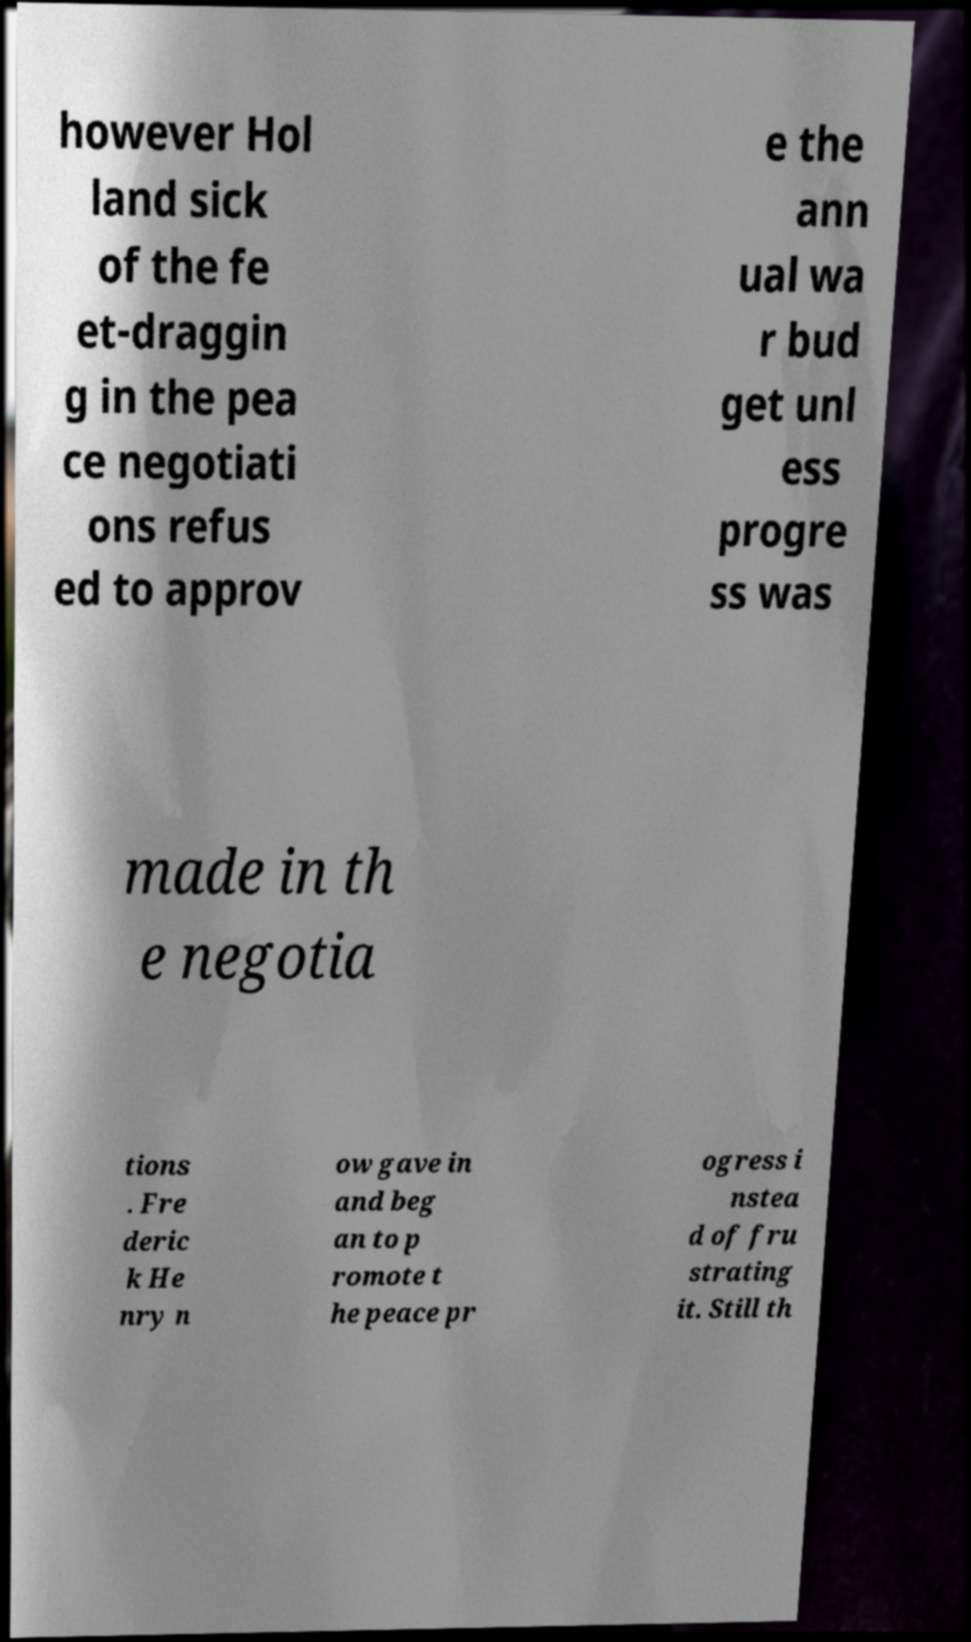What messages or text are displayed in this image? I need them in a readable, typed format. however Hol land sick of the fe et-draggin g in the pea ce negotiati ons refus ed to approv e the ann ual wa r bud get unl ess progre ss was made in th e negotia tions . Fre deric k He nry n ow gave in and beg an to p romote t he peace pr ogress i nstea d of fru strating it. Still th 